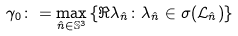<formula> <loc_0><loc_0><loc_500><loc_500>\gamma _ { 0 } \colon = \max _ { \hat { n } \in \mathbb { S } ^ { 3 } } \left \{ \Re \lambda _ { \hat { n } } \colon \lambda _ { \hat { n } } \in \sigma ( \mathcal { L } _ { \hat { n } } ) \right \}</formula> 